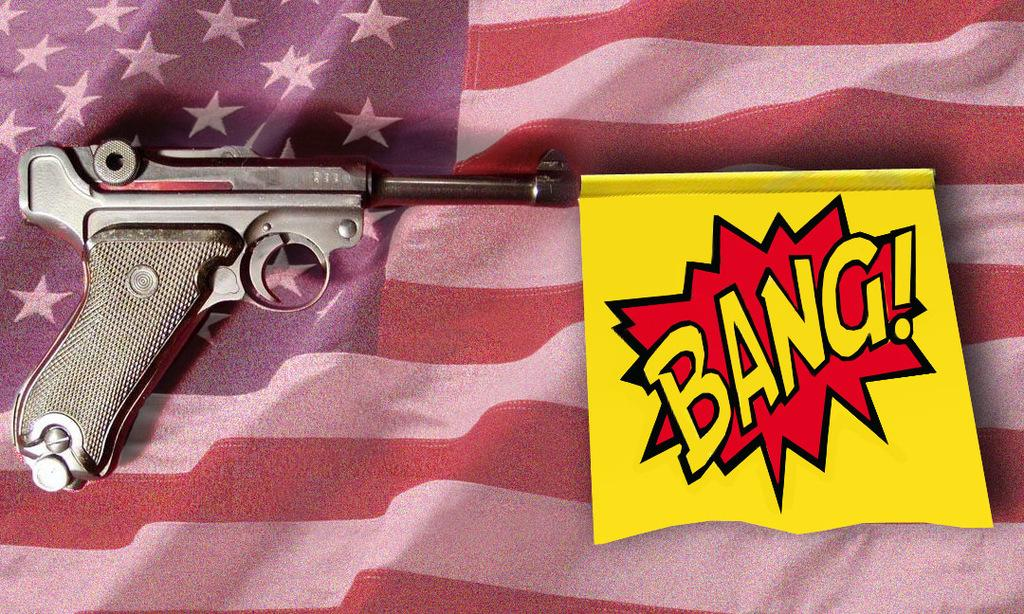What is present in the image that represents a symbol or country? There is a flag in the image. What is on the flag? There is a poster on the flag. What type of liquid can be seen flowing from the page in the image? There is no page or liquid present in the image; it only features a flag with a poster on it. 